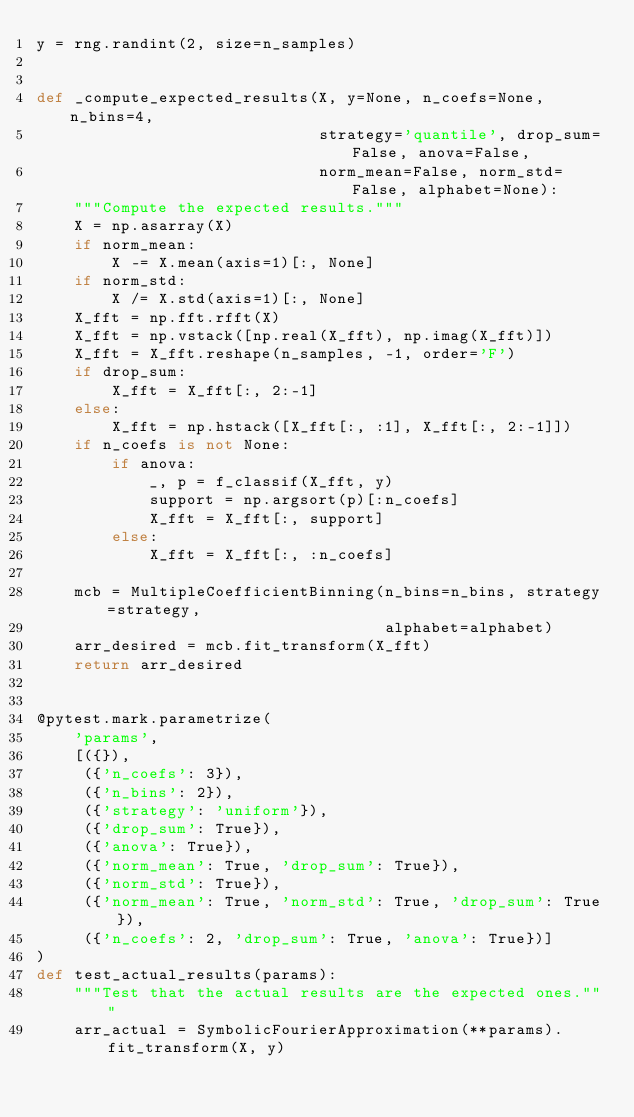Convert code to text. <code><loc_0><loc_0><loc_500><loc_500><_Python_>y = rng.randint(2, size=n_samples)


def _compute_expected_results(X, y=None, n_coefs=None, n_bins=4,
                              strategy='quantile', drop_sum=False, anova=False,
                              norm_mean=False, norm_std=False, alphabet=None):
    """Compute the expected results."""
    X = np.asarray(X)
    if norm_mean:
        X -= X.mean(axis=1)[:, None]
    if norm_std:
        X /= X.std(axis=1)[:, None]
    X_fft = np.fft.rfft(X)
    X_fft = np.vstack([np.real(X_fft), np.imag(X_fft)])
    X_fft = X_fft.reshape(n_samples, -1, order='F')
    if drop_sum:
        X_fft = X_fft[:, 2:-1]
    else:
        X_fft = np.hstack([X_fft[:, :1], X_fft[:, 2:-1]])
    if n_coefs is not None:
        if anova:
            _, p = f_classif(X_fft, y)
            support = np.argsort(p)[:n_coefs]
            X_fft = X_fft[:, support]
        else:
            X_fft = X_fft[:, :n_coefs]

    mcb = MultipleCoefficientBinning(n_bins=n_bins, strategy=strategy,
                                     alphabet=alphabet)
    arr_desired = mcb.fit_transform(X_fft)
    return arr_desired


@pytest.mark.parametrize(
    'params',
    [({}),
     ({'n_coefs': 3}),
     ({'n_bins': 2}),
     ({'strategy': 'uniform'}),
     ({'drop_sum': True}),
     ({'anova': True}),
     ({'norm_mean': True, 'drop_sum': True}),
     ({'norm_std': True}),
     ({'norm_mean': True, 'norm_std': True, 'drop_sum': True}),
     ({'n_coefs': 2, 'drop_sum': True, 'anova': True})]
)
def test_actual_results(params):
    """Test that the actual results are the expected ones."""
    arr_actual = SymbolicFourierApproximation(**params).fit_transform(X, y)</code> 